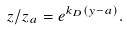<formula> <loc_0><loc_0><loc_500><loc_500>z / z _ { a } = e ^ { k _ { D } ( y - a ) } .</formula> 